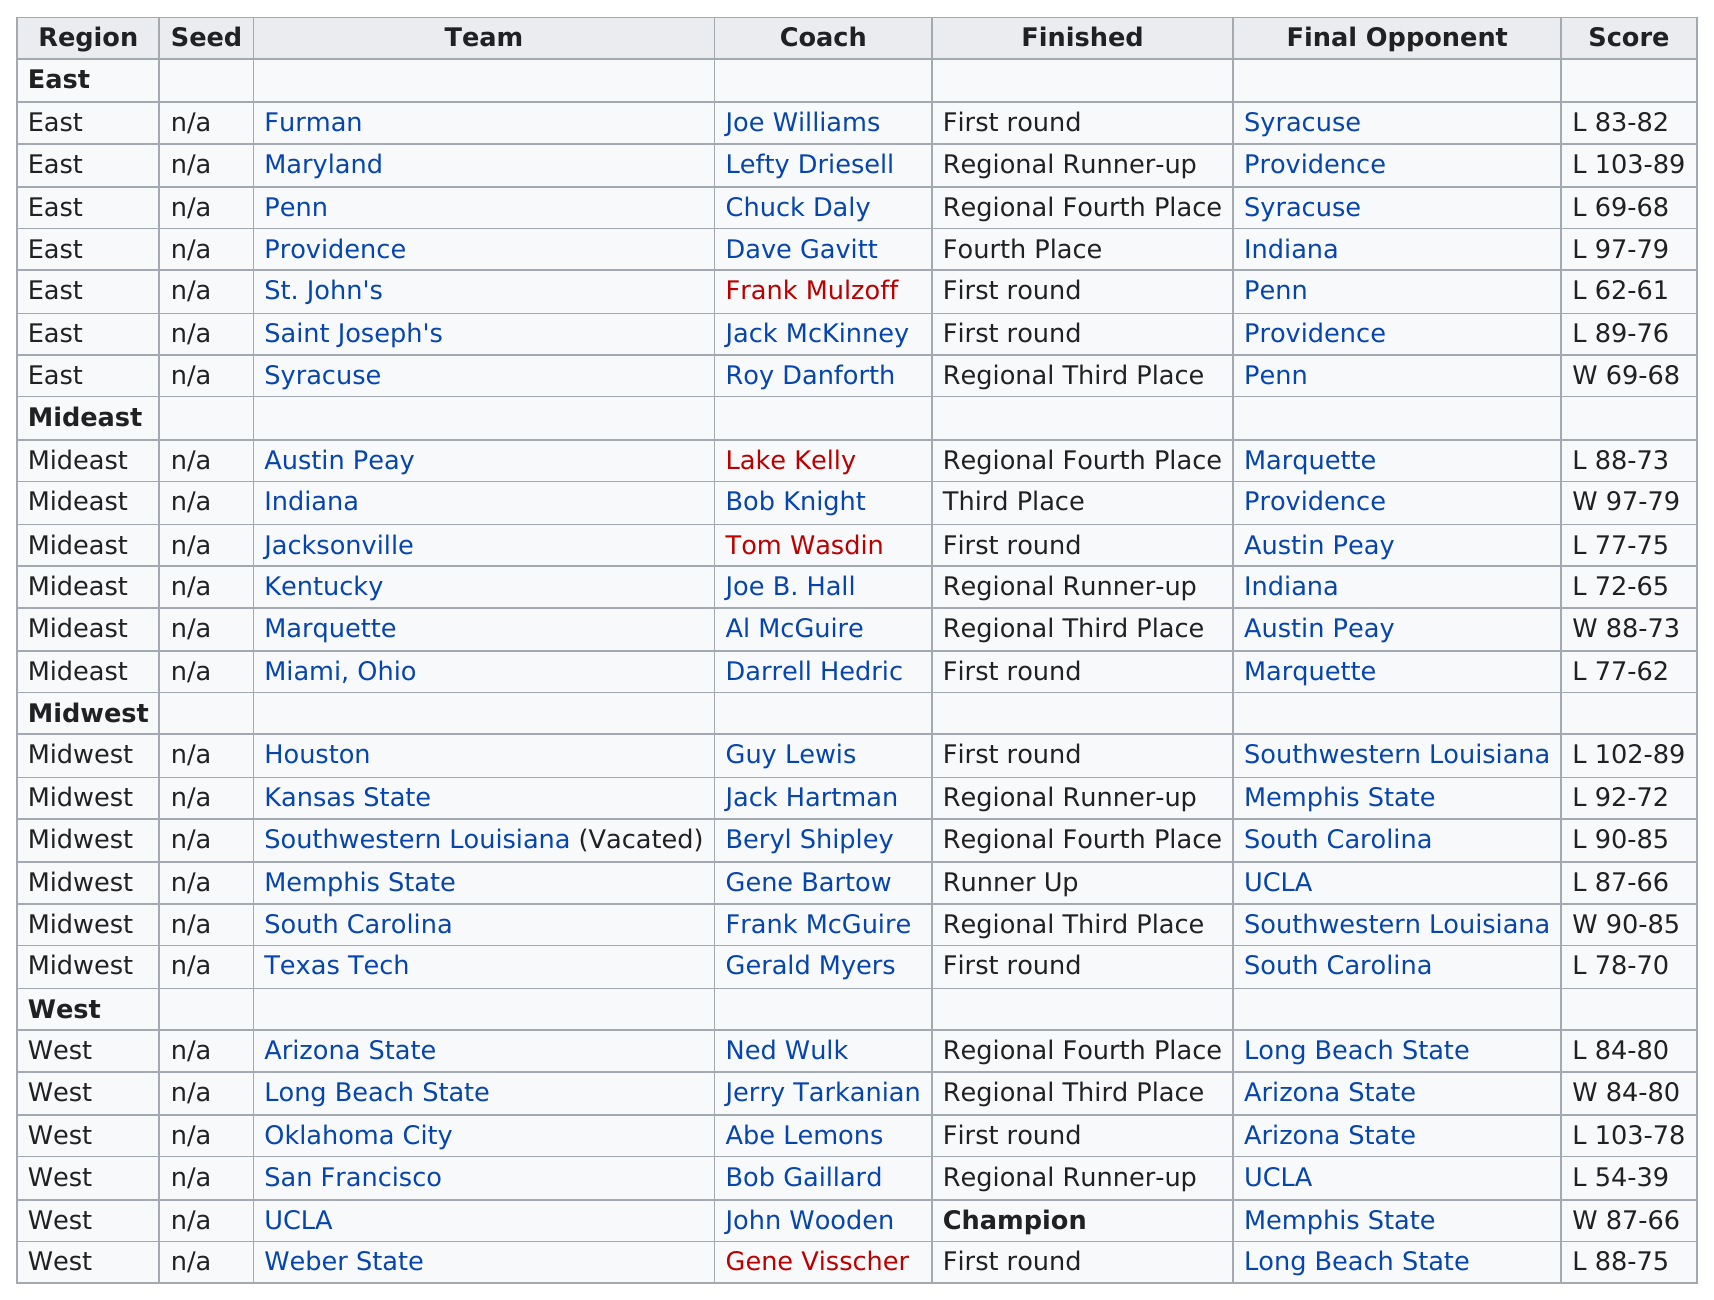Indicate a few pertinent items in this graphic. Out of the total number of teams that played in the tournament, 5 teams lost by three or fewer points in their final game. The San Francisco team scored the least out of all the teams. The East region finished most frequently in the first round among the four regions. There were two Midwest teams that played against Southwestern Louisiana as their final opponent. The Midwest region is located above the West region. 